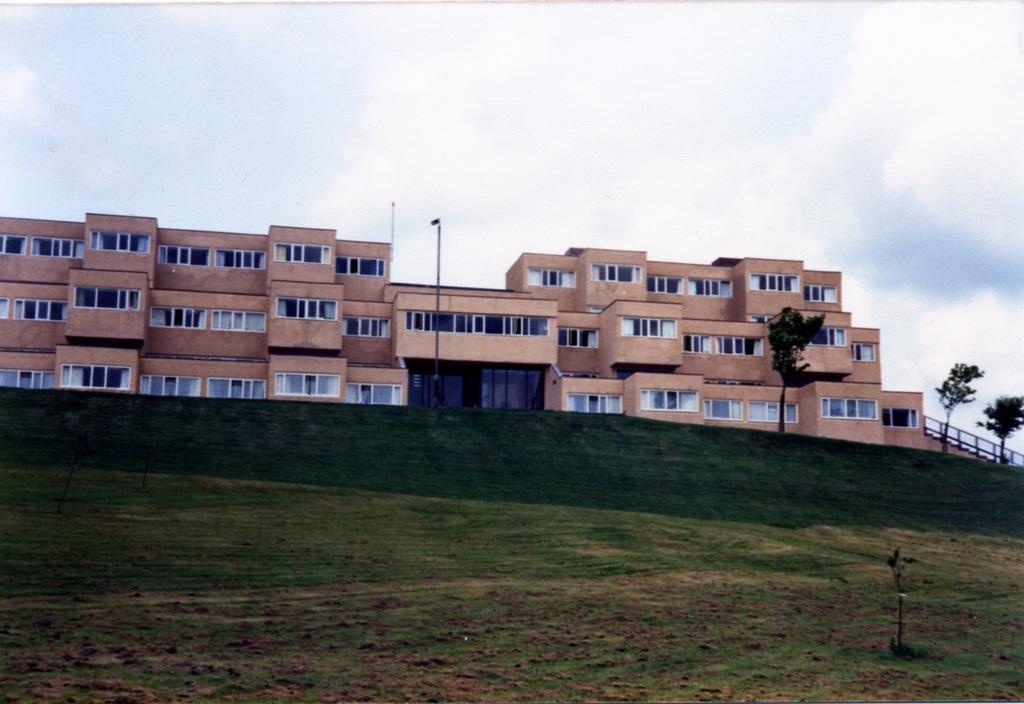Describe this image in one or two sentences. In the image we can see the building and these are the windows of the building. We can even see there are trees and poles. Here we can see the grass and the cloudy sky. 